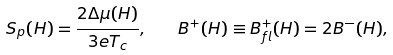<formula> <loc_0><loc_0><loc_500><loc_500>S _ { p } ( H ) = \frac { 2 \Delta \mu ( H ) } { 3 e T _ { c } } , \quad B ^ { + } ( H ) \equiv B _ { f l } ^ { + } ( H ) = 2 B ^ { - } ( H ) ,</formula> 